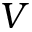Convert formula to latex. <formula><loc_0><loc_0><loc_500><loc_500>V</formula> 